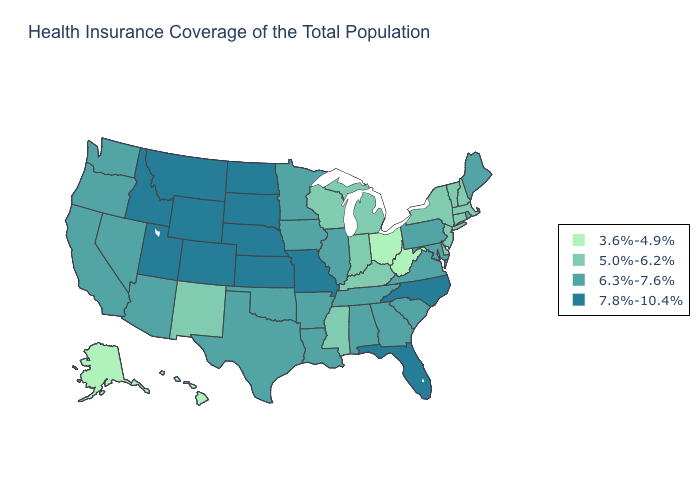Is the legend a continuous bar?
Quick response, please. No. What is the value of New Hampshire?
Keep it brief. 5.0%-6.2%. What is the value of Iowa?
Be succinct. 6.3%-7.6%. Does Delaware have the highest value in the South?
Concise answer only. No. Does Indiana have a higher value than West Virginia?
Answer briefly. Yes. What is the lowest value in states that border New Hampshire?
Give a very brief answer. 5.0%-6.2%. Name the states that have a value in the range 6.3%-7.6%?
Give a very brief answer. Alabama, Arizona, Arkansas, California, Georgia, Illinois, Iowa, Louisiana, Maine, Maryland, Minnesota, Nevada, Oklahoma, Oregon, Pennsylvania, Rhode Island, South Carolina, Tennessee, Texas, Virginia, Washington. What is the value of Hawaii?
Quick response, please. 3.6%-4.9%. Name the states that have a value in the range 3.6%-4.9%?
Short answer required. Alaska, Hawaii, Ohio, West Virginia. Among the states that border Massachusetts , which have the highest value?
Be succinct. Rhode Island. How many symbols are there in the legend?
Answer briefly. 4. What is the lowest value in the USA?
Keep it brief. 3.6%-4.9%. What is the value of Michigan?
Give a very brief answer. 5.0%-6.2%. Does the map have missing data?
Answer briefly. No. 